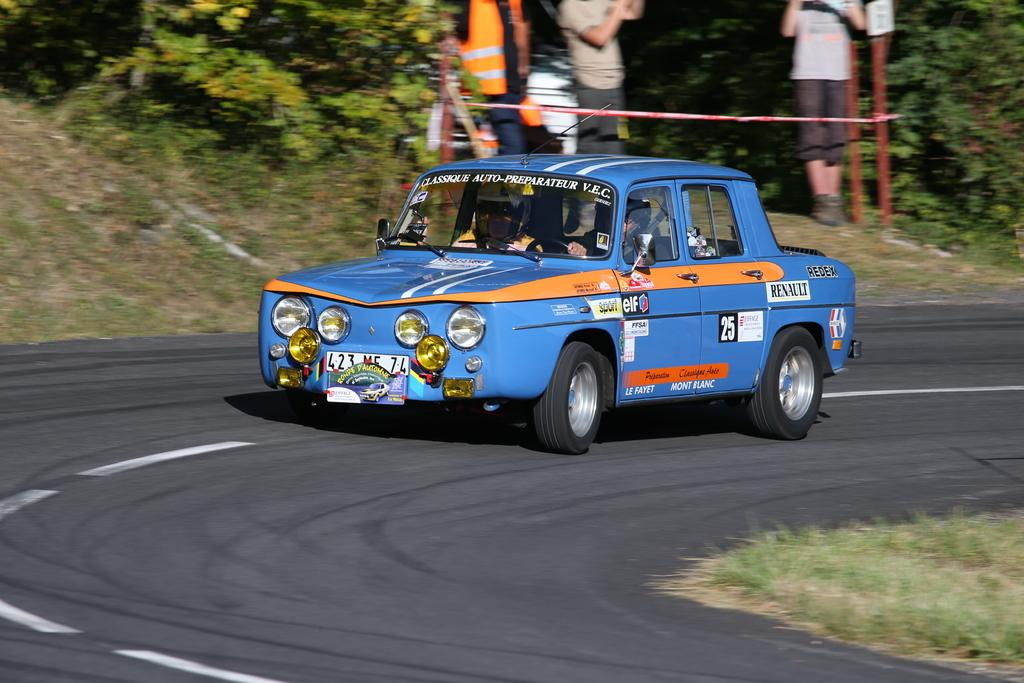What is on the road in the image? There is a car on the road in the image. Who is inside the car? There are two persons inside the car. What type of vegetation can be seen in the image? There is grass visible in the image, as well as trees. What objects are present in the image besides the car and persons? There are rods and a board in the image. How many people are in the image? There are three persons in the image. What type of payment is required to enter the station in the image? There is no station present in the image, so no payment is required. What show is being performed by the three persons in the image? There is no show being performed by the three persons in the image; they are simply present in the scene. 